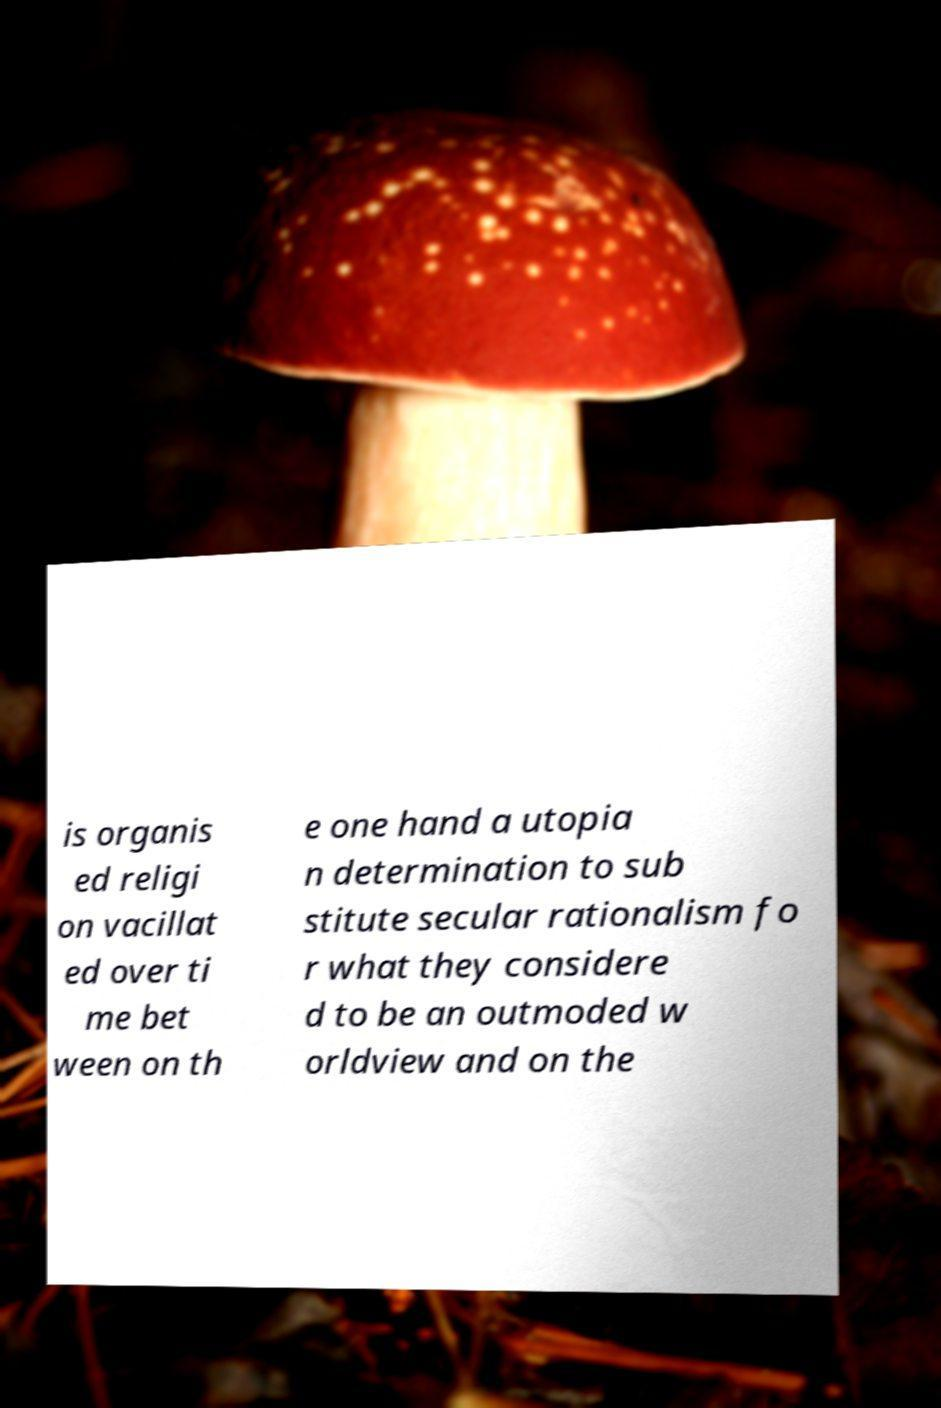What messages or text are displayed in this image? I need them in a readable, typed format. is organis ed religi on vacillat ed over ti me bet ween on th e one hand a utopia n determination to sub stitute secular rationalism fo r what they considere d to be an outmoded w orldview and on the 